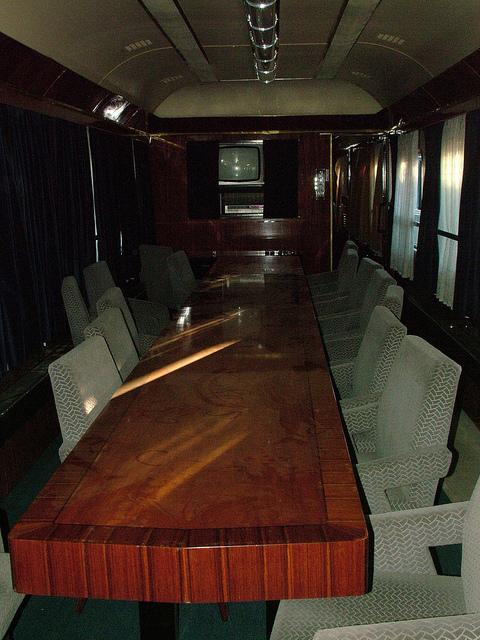What city is this in?
Short answer required. New york. Is this a restaurant?
Answer briefly. No. Is this a fancy train?
Quick response, please. Yes. What material is the table made of?
Answer briefly. Wood. Is the table long or wide?
Write a very short answer. Long. 